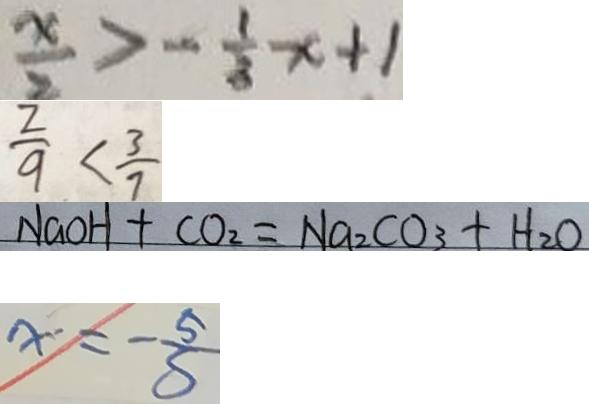Convert formula to latex. <formula><loc_0><loc_0><loc_500><loc_500>\frac { x } { 2 } > - \frac { 1 } { 3 } x + 1 
 \frac { 2 } { 9 } < \frac { 3 } { 7 } 
 N a O H + C O _ { 2 } = N a _ { 2 } C O _ { 3 } + H _ { 2 } O 
 x = - \frac { 5 } { S }</formula> 